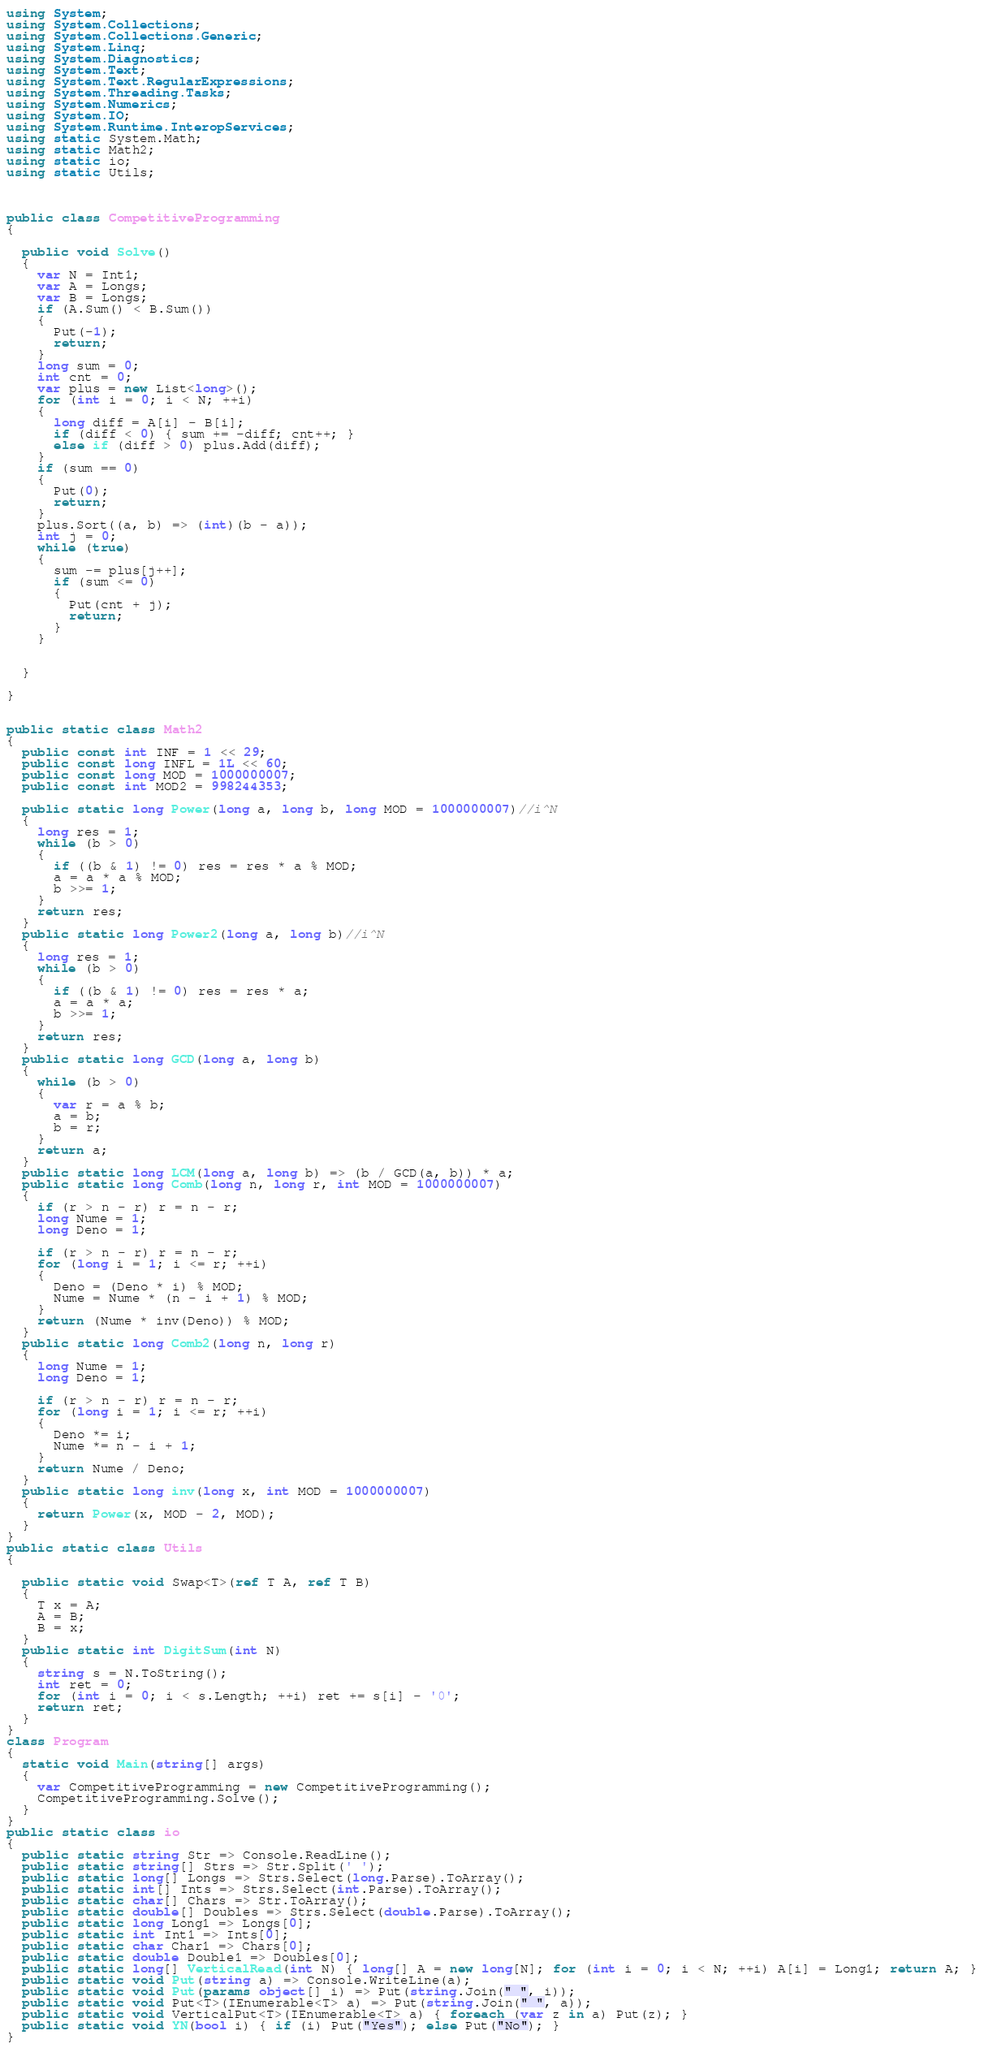Convert code to text. <code><loc_0><loc_0><loc_500><loc_500><_C#_>using System;
using System.Collections;
using System.Collections.Generic;
using System.Linq;
using System.Diagnostics;
using System.Text;
using System.Text.RegularExpressions;
using System.Threading.Tasks;
using System.Numerics;
using System.IO;
using System.Runtime.InteropServices;
using static System.Math;
using static Math2;
using static io;
using static Utils;



public class CompetitiveProgramming
{

  public void Solve()
  {
    var N = Int1;
    var A = Longs;
    var B = Longs;
    if (A.Sum() < B.Sum())
    {
      Put(-1);
      return;
    }
    long sum = 0;
    int cnt = 0;
    var plus = new List<long>();
    for (int i = 0; i < N; ++i)
    {
      long diff = A[i] - B[i];
      if (diff < 0) { sum += -diff; cnt++; }
      else if (diff > 0) plus.Add(diff);
    }
    if (sum == 0)
    {
      Put(0);
      return;
    }
    plus.Sort((a, b) => (int)(b - a));
    int j = 0;
    while (true)
    {
      sum -= plus[j++];
      if (sum <= 0)
      {
        Put(cnt + j);
        return;
      }
    }


  }

}


public static class Math2
{
  public const int INF = 1 << 29;
  public const long INFL = 1L << 60;
  public const long MOD = 1000000007;
  public const int MOD2 = 998244353;

  public static long Power(long a, long b, long MOD = 1000000007)//i^N
  {
    long res = 1;
    while (b > 0)
    {
      if ((b & 1) != 0) res = res * a % MOD;
      a = a * a % MOD;
      b >>= 1;
    }
    return res;
  }
  public static long Power2(long a, long b)//i^N
  {
    long res = 1;
    while (b > 0)
    {
      if ((b & 1) != 0) res = res * a;
      a = a * a;
      b >>= 1;
    }
    return res;
  }
  public static long GCD(long a, long b)
  {
    while (b > 0)
    {
      var r = a % b;
      a = b;
      b = r;
    }
    return a;
  }
  public static long LCM(long a, long b) => (b / GCD(a, b)) * a;
  public static long Comb(long n, long r, int MOD = 1000000007)
  {
    if (r > n - r) r = n - r;
    long Nume = 1;
    long Deno = 1;

    if (r > n - r) r = n - r;
    for (long i = 1; i <= r; ++i)
    {
      Deno = (Deno * i) % MOD;
      Nume = Nume * (n - i + 1) % MOD;
    }
    return (Nume * inv(Deno)) % MOD;
  }
  public static long Comb2(long n, long r)
  {
    long Nume = 1;
    long Deno = 1;

    if (r > n - r) r = n - r;
    for (long i = 1; i <= r; ++i)
    {
      Deno *= i;
      Nume *= n - i + 1;
    }
    return Nume / Deno;
  }
  public static long inv(long x, int MOD = 1000000007)
  {
    return Power(x, MOD - 2, MOD);
  }
}
public static class Utils
{

  public static void Swap<T>(ref T A, ref T B)
  {
    T x = A;
    A = B;
    B = x;
  }
  public static int DigitSum(int N)
  {
    string s = N.ToString();
    int ret = 0;
    for (int i = 0; i < s.Length; ++i) ret += s[i] - '0';
    return ret;
  }
}
class Program
{
  static void Main(string[] args)
  {
    var CompetitiveProgramming = new CompetitiveProgramming();
    CompetitiveProgramming.Solve();
  }
}
public static class io
{
  public static string Str => Console.ReadLine();
  public static string[] Strs => Str.Split(' ');
  public static long[] Longs => Strs.Select(long.Parse).ToArray();
  public static int[] Ints => Strs.Select(int.Parse).ToArray();
  public static char[] Chars => Str.ToArray();
  public static double[] Doubles => Strs.Select(double.Parse).ToArray();
  public static long Long1 => Longs[0];
  public static int Int1 => Ints[0];
  public static char Char1 => Chars[0];
  public static double Double1 => Doubles[0];
  public static long[] VerticalRead(int N) { long[] A = new long[N]; for (int i = 0; i < N; ++i) A[i] = Long1; return A; }
  public static void Put(string a) => Console.WriteLine(a);
  public static void Put(params object[] i) => Put(string.Join(" ", i));
  public static void Put<T>(IEnumerable<T> a) => Put(string.Join(" ", a));
  public static void VerticalPut<T>(IEnumerable<T> a) { foreach (var z in a) Put(z); }
  public static void YN(bool i) { if (i) Put("Yes"); else Put("No"); }
}</code> 